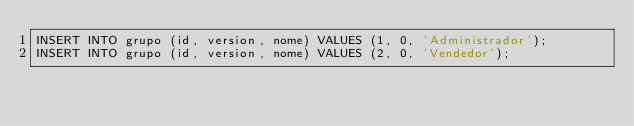Convert code to text. <code><loc_0><loc_0><loc_500><loc_500><_SQL_>INSERT INTO grupo (id, version, nome) VALUES (1, 0, 'Administrador');
INSERT INTO grupo (id, version, nome) VALUES (2, 0, 'Vendedor');</code> 